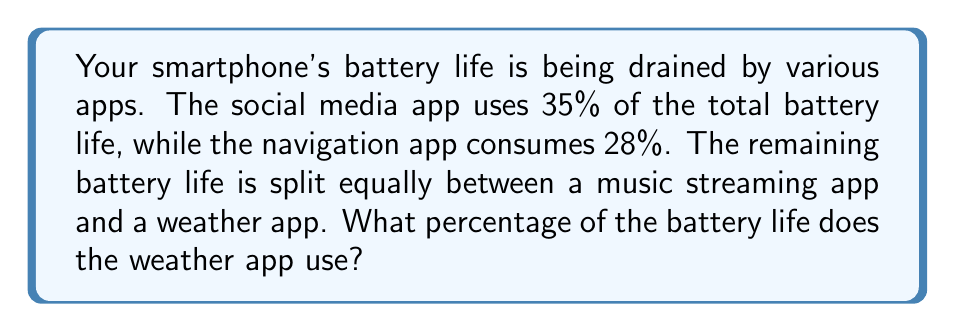Could you help me with this problem? Let's approach this step-by-step:

1) First, let's calculate the total percentage of battery life used by the social media and navigation apps:
   $35\% + 28\% = 63\%$

2) The remaining percentage of battery life is:
   $100\% - 63\% = 37\%$

3) We're told that this remaining 37% is split equally between the music streaming app and the weather app. To find out how much each of these apps uses, we need to divide 37% by 2:

   $\frac{37\%}{2} = 18.5\%$

4) Therefore, the weather app uses 18.5% of the battery life.

This solution doesn't rely on any fancy algorithms or high-tech calculations, just simple arithmetic - something our jaded, skeptical persona might appreciate.
Answer: 18.5% 